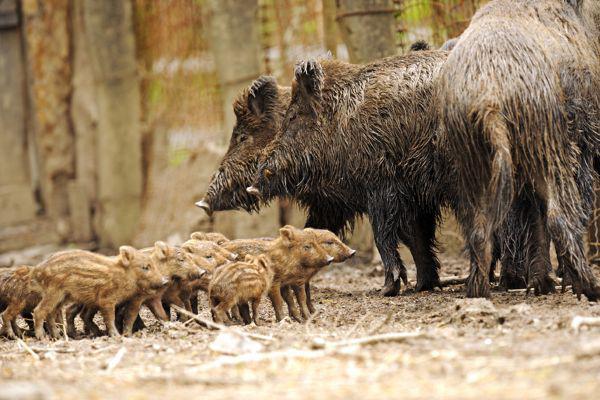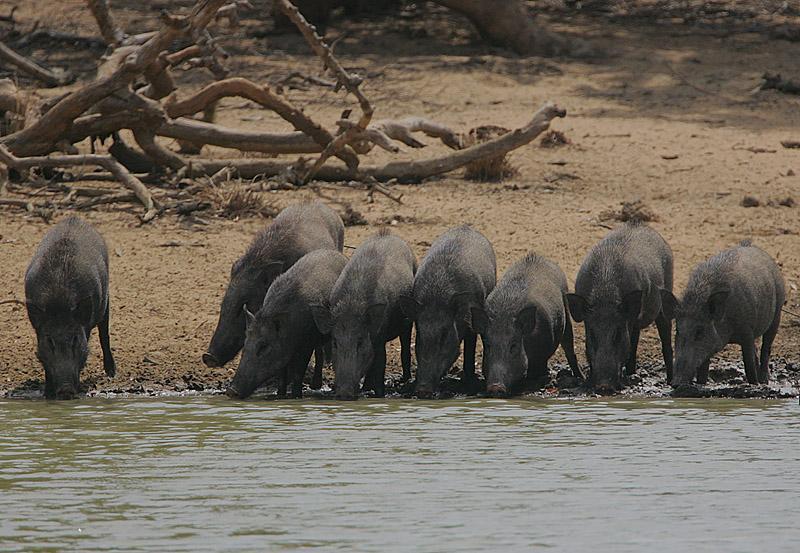The first image is the image on the left, the second image is the image on the right. Analyze the images presented: Is the assertion "There is black mother boar laying the dirt with at least six nursing piglets at her belly." valid? Answer yes or no. No. 